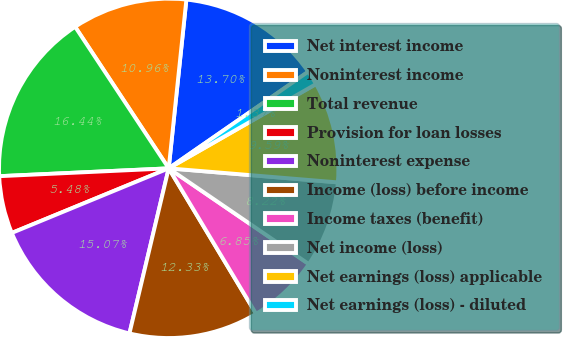Convert chart to OTSL. <chart><loc_0><loc_0><loc_500><loc_500><pie_chart><fcel>Net interest income<fcel>Noninterest income<fcel>Total revenue<fcel>Provision for loan losses<fcel>Noninterest expense<fcel>Income (loss) before income<fcel>Income taxes (benefit)<fcel>Net income (loss)<fcel>Net earnings (loss) applicable<fcel>Net earnings (loss) - diluted<nl><fcel>13.7%<fcel>10.96%<fcel>16.44%<fcel>5.48%<fcel>15.07%<fcel>12.33%<fcel>6.85%<fcel>8.22%<fcel>9.59%<fcel>1.37%<nl></chart> 